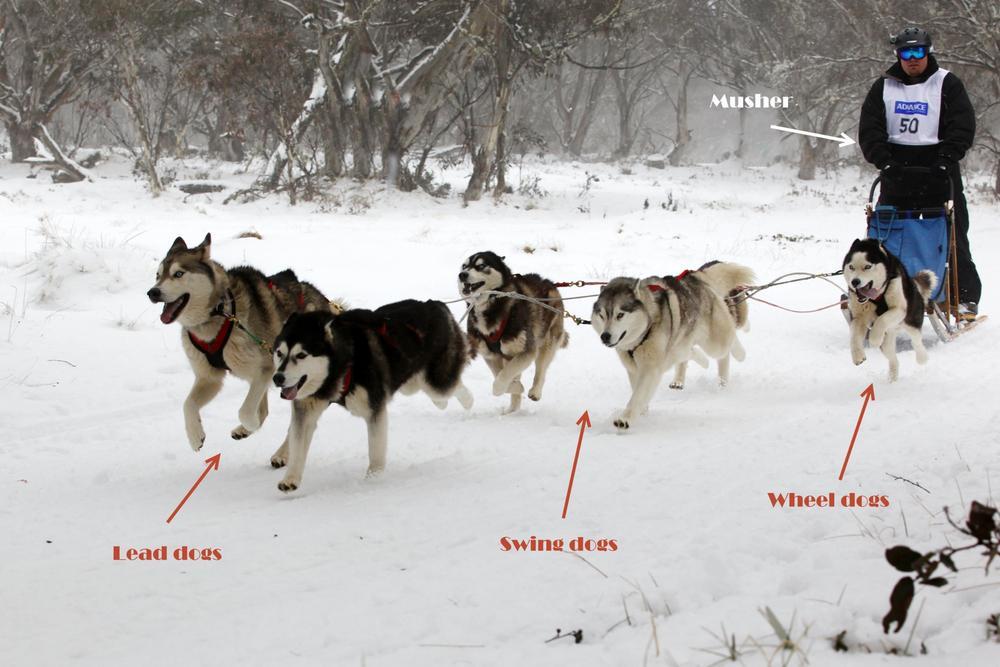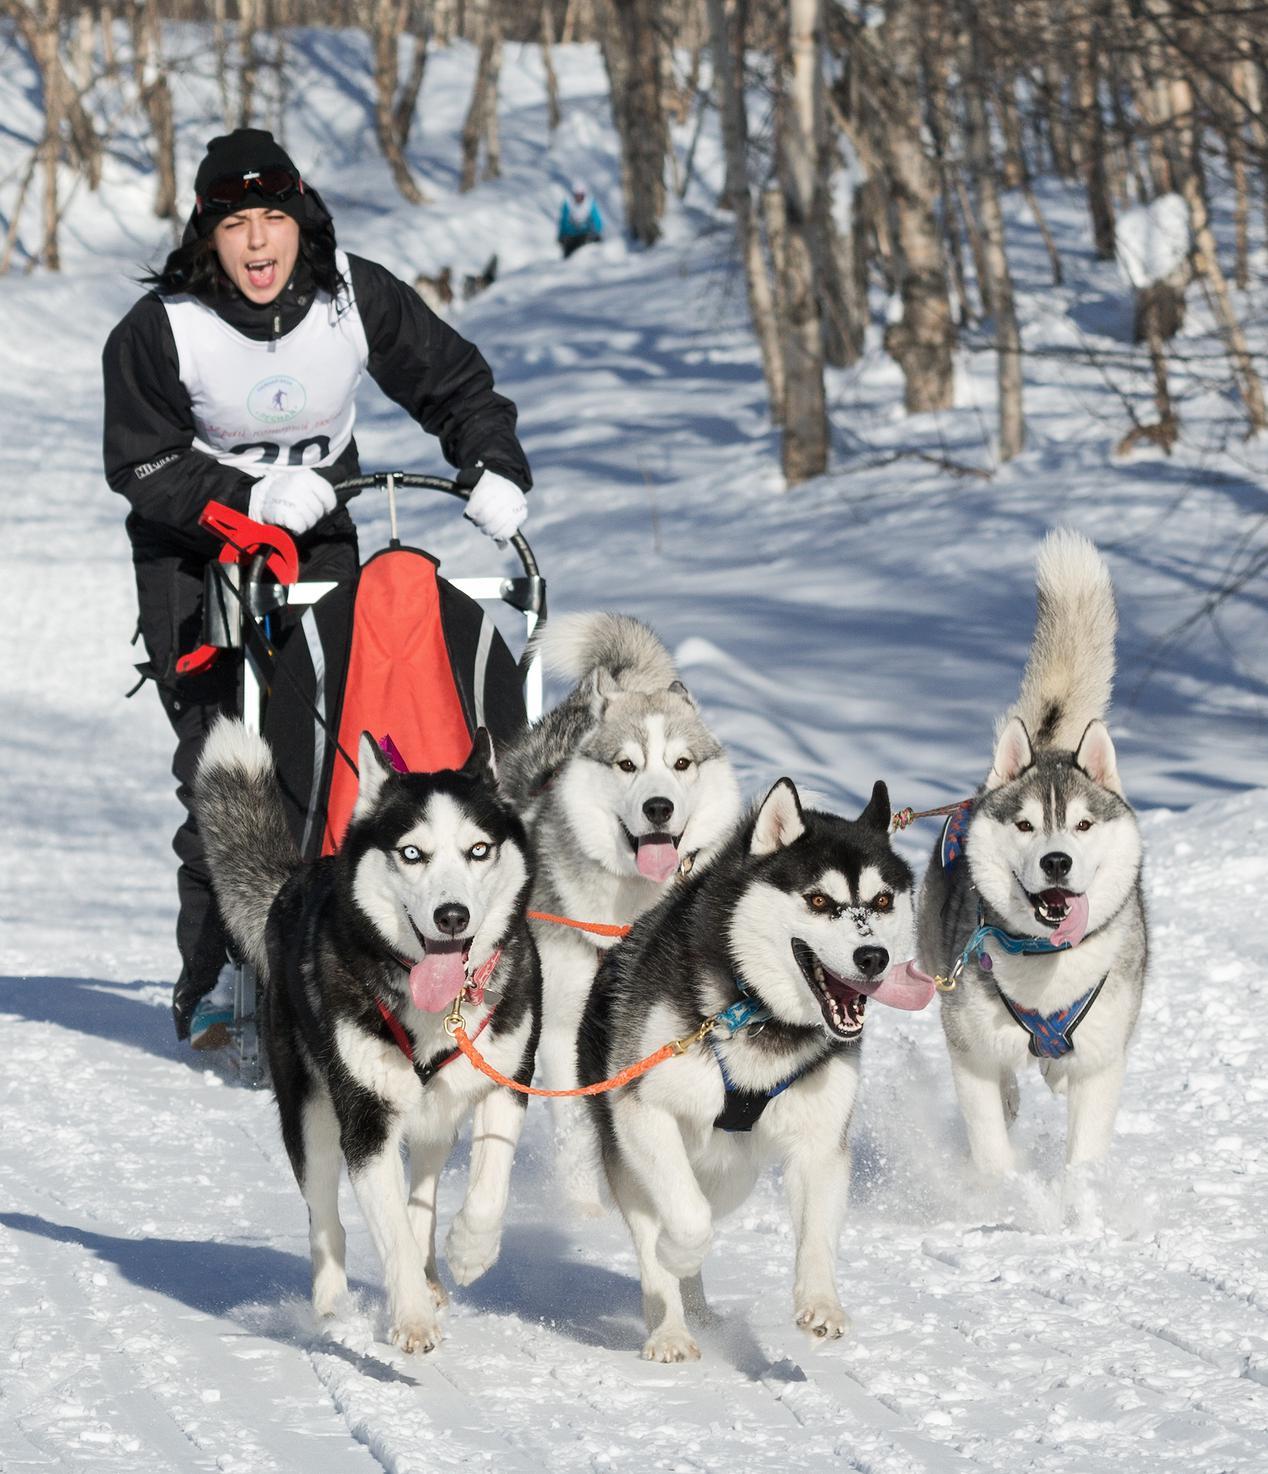The first image is the image on the left, the second image is the image on the right. Examine the images to the left and right. Is the description "Mountains are visible behind the sled dogs" accurate? Answer yes or no. No. The first image is the image on the left, the second image is the image on the right. For the images shown, is this caption "Right image shows sled dogs moving rightward, with a mountain backdrop." true? Answer yes or no. No. 